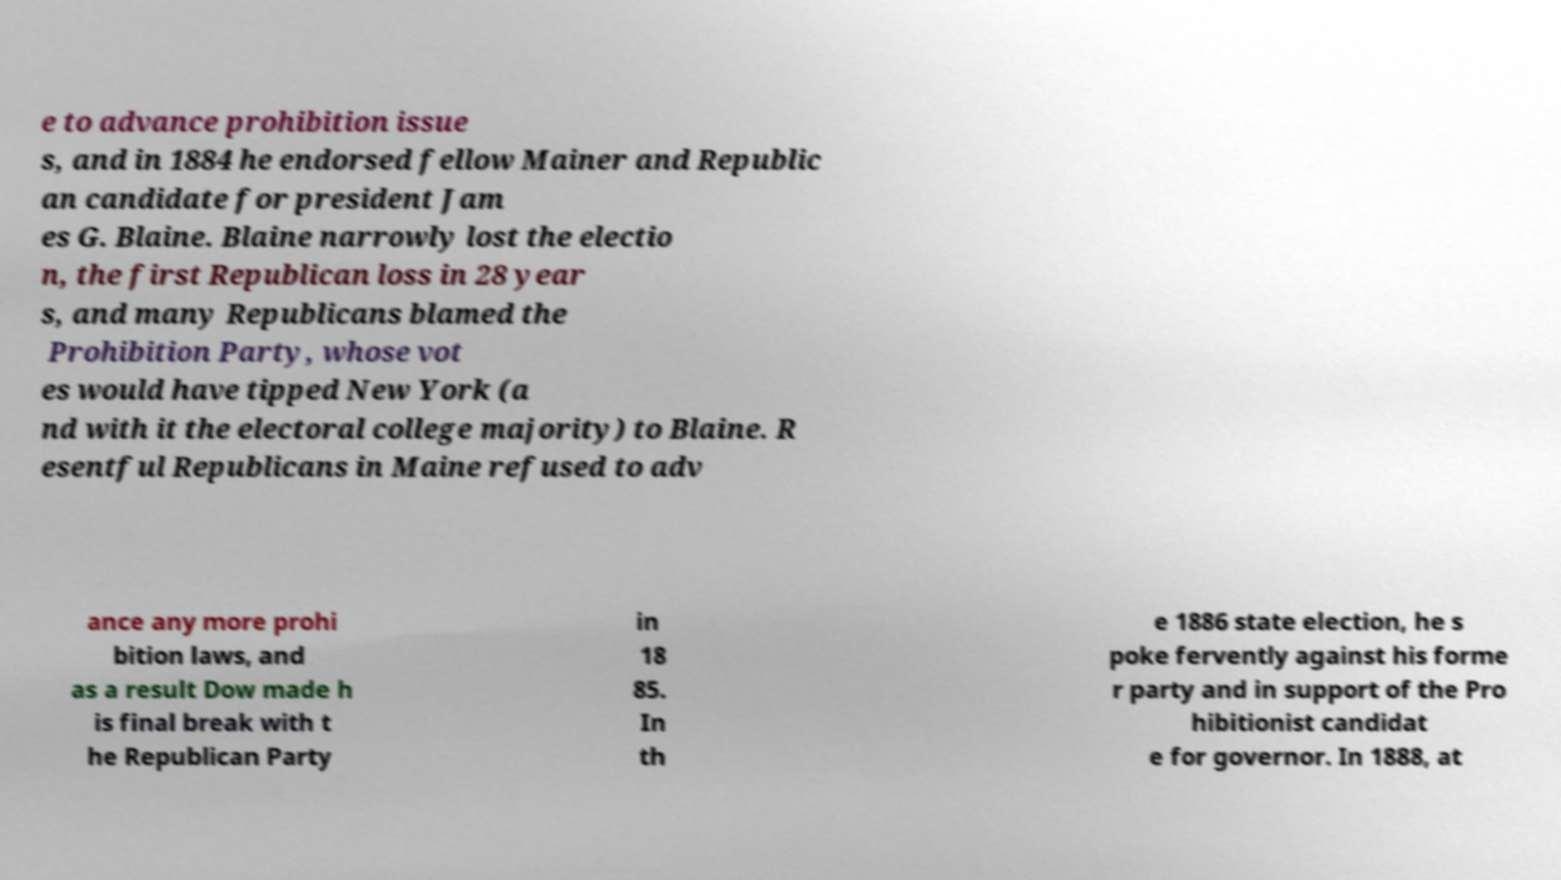Could you assist in decoding the text presented in this image and type it out clearly? e to advance prohibition issue s, and in 1884 he endorsed fellow Mainer and Republic an candidate for president Jam es G. Blaine. Blaine narrowly lost the electio n, the first Republican loss in 28 year s, and many Republicans blamed the Prohibition Party, whose vot es would have tipped New York (a nd with it the electoral college majority) to Blaine. R esentful Republicans in Maine refused to adv ance any more prohi bition laws, and as a result Dow made h is final break with t he Republican Party in 18 85. In th e 1886 state election, he s poke fervently against his forme r party and in support of the Pro hibitionist candidat e for governor. In 1888, at 